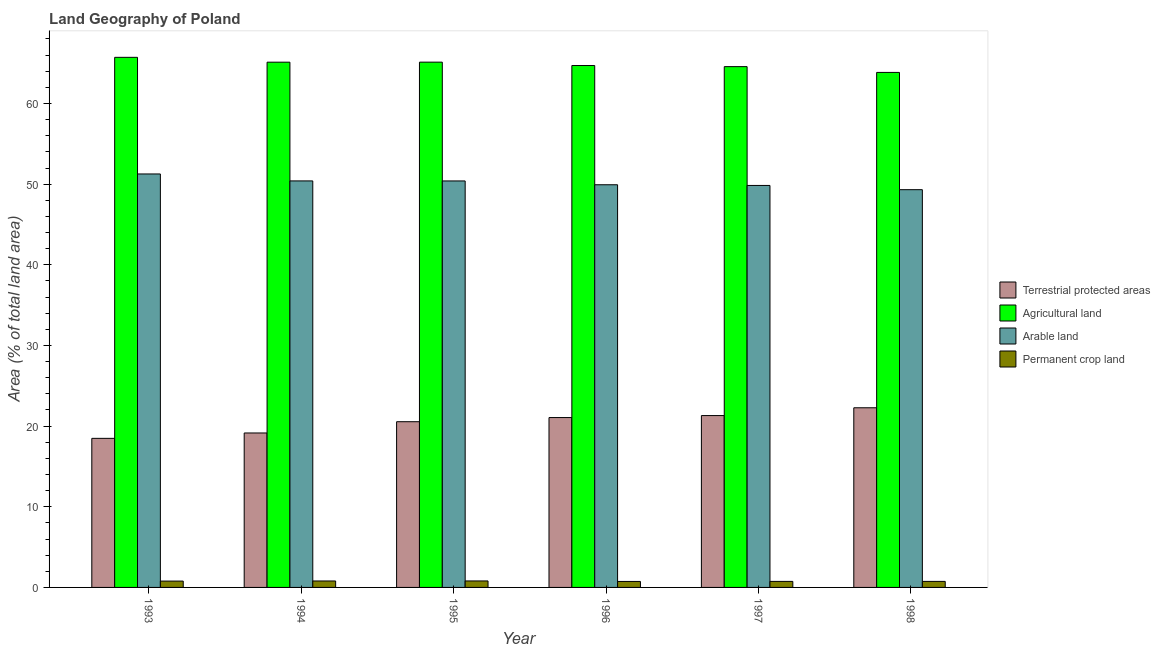Are the number of bars on each tick of the X-axis equal?
Your answer should be compact. Yes. What is the percentage of area under agricultural land in 1993?
Make the answer very short. 65.72. Across all years, what is the maximum percentage of land under terrestrial protection?
Your response must be concise. 22.27. Across all years, what is the minimum percentage of area under agricultural land?
Provide a succinct answer. 63.85. What is the total percentage of area under agricultural land in the graph?
Your response must be concise. 389.1. What is the difference between the percentage of area under permanent crop land in 1994 and that in 1998?
Keep it short and to the point. 0.05. What is the difference between the percentage of area under agricultural land in 1995 and the percentage of area under permanent crop land in 1994?
Your answer should be very brief. 0. What is the average percentage of area under agricultural land per year?
Keep it short and to the point. 64.85. In the year 1997, what is the difference between the percentage of area under permanent crop land and percentage of area under arable land?
Your answer should be compact. 0. What is the ratio of the percentage of area under permanent crop land in 1996 to that in 1997?
Your answer should be compact. 0.99. Is the percentage of area under permanent crop land in 1993 less than that in 1996?
Your response must be concise. No. What is the difference between the highest and the second highest percentage of area under agricultural land?
Give a very brief answer. 0.6. What is the difference between the highest and the lowest percentage of land under terrestrial protection?
Your answer should be compact. 3.79. In how many years, is the percentage of area under agricultural land greater than the average percentage of area under agricultural land taken over all years?
Offer a terse response. 3. Is the sum of the percentage of area under permanent crop land in 1993 and 1996 greater than the maximum percentage of area under arable land across all years?
Keep it short and to the point. Yes. What does the 4th bar from the left in 1995 represents?
Your response must be concise. Permanent crop land. What does the 4th bar from the right in 1995 represents?
Keep it short and to the point. Terrestrial protected areas. Where does the legend appear in the graph?
Offer a very short reply. Center right. How many legend labels are there?
Offer a terse response. 4. How are the legend labels stacked?
Your answer should be very brief. Vertical. What is the title of the graph?
Offer a very short reply. Land Geography of Poland. Does "Others" appear as one of the legend labels in the graph?
Offer a very short reply. No. What is the label or title of the Y-axis?
Offer a terse response. Area (% of total land area). What is the Area (% of total land area) in Terrestrial protected areas in 1993?
Offer a terse response. 18.48. What is the Area (% of total land area) of Agricultural land in 1993?
Provide a succinct answer. 65.72. What is the Area (% of total land area) of Arable land in 1993?
Make the answer very short. 51.26. What is the Area (% of total land area) of Permanent crop land in 1993?
Your answer should be very brief. 0.79. What is the Area (% of total land area) of Terrestrial protected areas in 1994?
Give a very brief answer. 19.15. What is the Area (% of total land area) of Agricultural land in 1994?
Provide a short and direct response. 65.12. What is the Area (% of total land area) of Arable land in 1994?
Give a very brief answer. 50.4. What is the Area (% of total land area) of Permanent crop land in 1994?
Ensure brevity in your answer.  0.8. What is the Area (% of total land area) in Terrestrial protected areas in 1995?
Offer a very short reply. 20.55. What is the Area (% of total land area) in Agricultural land in 1995?
Ensure brevity in your answer.  65.12. What is the Area (% of total land area) in Arable land in 1995?
Make the answer very short. 50.4. What is the Area (% of total land area) in Permanent crop land in 1995?
Ensure brevity in your answer.  0.8. What is the Area (% of total land area) in Terrestrial protected areas in 1996?
Offer a very short reply. 21.06. What is the Area (% of total land area) in Agricultural land in 1996?
Offer a very short reply. 64.71. What is the Area (% of total land area) of Arable land in 1996?
Provide a succinct answer. 49.92. What is the Area (% of total land area) of Permanent crop land in 1996?
Ensure brevity in your answer.  0.74. What is the Area (% of total land area) of Terrestrial protected areas in 1997?
Your response must be concise. 21.31. What is the Area (% of total land area) in Agricultural land in 1997?
Ensure brevity in your answer.  64.57. What is the Area (% of total land area) of Arable land in 1997?
Make the answer very short. 49.84. What is the Area (% of total land area) of Permanent crop land in 1997?
Make the answer very short. 0.75. What is the Area (% of total land area) of Terrestrial protected areas in 1998?
Keep it short and to the point. 22.27. What is the Area (% of total land area) of Agricultural land in 1998?
Ensure brevity in your answer.  63.85. What is the Area (% of total land area) of Arable land in 1998?
Make the answer very short. 49.31. What is the Area (% of total land area) in Permanent crop land in 1998?
Provide a succinct answer. 0.75. Across all years, what is the maximum Area (% of total land area) in Terrestrial protected areas?
Make the answer very short. 22.27. Across all years, what is the maximum Area (% of total land area) of Agricultural land?
Provide a short and direct response. 65.72. Across all years, what is the maximum Area (% of total land area) of Arable land?
Ensure brevity in your answer.  51.26. Across all years, what is the maximum Area (% of total land area) of Permanent crop land?
Give a very brief answer. 0.8. Across all years, what is the minimum Area (% of total land area) in Terrestrial protected areas?
Keep it short and to the point. 18.48. Across all years, what is the minimum Area (% of total land area) of Agricultural land?
Make the answer very short. 63.85. Across all years, what is the minimum Area (% of total land area) of Arable land?
Offer a very short reply. 49.31. Across all years, what is the minimum Area (% of total land area) in Permanent crop land?
Your answer should be compact. 0.74. What is the total Area (% of total land area) in Terrestrial protected areas in the graph?
Offer a very short reply. 122.82. What is the total Area (% of total land area) of Agricultural land in the graph?
Offer a very short reply. 389.1. What is the total Area (% of total land area) of Arable land in the graph?
Your answer should be very brief. 301.13. What is the total Area (% of total land area) of Permanent crop land in the graph?
Offer a terse response. 4.63. What is the difference between the Area (% of total land area) of Terrestrial protected areas in 1993 and that in 1994?
Your response must be concise. -0.67. What is the difference between the Area (% of total land area) in Agricultural land in 1993 and that in 1994?
Keep it short and to the point. 0.6. What is the difference between the Area (% of total land area) of Arable land in 1993 and that in 1994?
Your answer should be compact. 0.86. What is the difference between the Area (% of total land area) of Permanent crop land in 1993 and that in 1994?
Give a very brief answer. -0.01. What is the difference between the Area (% of total land area) of Terrestrial protected areas in 1993 and that in 1995?
Provide a short and direct response. -2.06. What is the difference between the Area (% of total land area) in Agricultural land in 1993 and that in 1995?
Provide a short and direct response. 0.6. What is the difference between the Area (% of total land area) of Arable land in 1993 and that in 1995?
Offer a terse response. 0.87. What is the difference between the Area (% of total land area) of Permanent crop land in 1993 and that in 1995?
Keep it short and to the point. -0.02. What is the difference between the Area (% of total land area) in Terrestrial protected areas in 1993 and that in 1996?
Give a very brief answer. -2.58. What is the difference between the Area (% of total land area) of Agricultural land in 1993 and that in 1996?
Your answer should be compact. 1.02. What is the difference between the Area (% of total land area) in Arable land in 1993 and that in 1996?
Offer a terse response. 1.34. What is the difference between the Area (% of total land area) in Permanent crop land in 1993 and that in 1996?
Make the answer very short. 0.05. What is the difference between the Area (% of total land area) in Terrestrial protected areas in 1993 and that in 1997?
Make the answer very short. -2.82. What is the difference between the Area (% of total land area) of Agricultural land in 1993 and that in 1997?
Give a very brief answer. 1.15. What is the difference between the Area (% of total land area) in Arable land in 1993 and that in 1997?
Your answer should be compact. 1.42. What is the difference between the Area (% of total land area) in Permanent crop land in 1993 and that in 1997?
Offer a very short reply. 0.04. What is the difference between the Area (% of total land area) of Terrestrial protected areas in 1993 and that in 1998?
Keep it short and to the point. -3.79. What is the difference between the Area (% of total land area) of Agricultural land in 1993 and that in 1998?
Ensure brevity in your answer.  1.87. What is the difference between the Area (% of total land area) of Arable land in 1993 and that in 1998?
Your answer should be very brief. 1.95. What is the difference between the Area (% of total land area) of Permanent crop land in 1993 and that in 1998?
Make the answer very short. 0.04. What is the difference between the Area (% of total land area) in Terrestrial protected areas in 1994 and that in 1995?
Provide a succinct answer. -1.4. What is the difference between the Area (% of total land area) of Agricultural land in 1994 and that in 1995?
Your answer should be compact. -0. What is the difference between the Area (% of total land area) in Arable land in 1994 and that in 1995?
Provide a short and direct response. 0. What is the difference between the Area (% of total land area) of Permanent crop land in 1994 and that in 1995?
Your response must be concise. -0. What is the difference between the Area (% of total land area) in Terrestrial protected areas in 1994 and that in 1996?
Give a very brief answer. -1.91. What is the difference between the Area (% of total land area) of Agricultural land in 1994 and that in 1996?
Offer a terse response. 0.41. What is the difference between the Area (% of total land area) in Arable land in 1994 and that in 1996?
Give a very brief answer. 0.48. What is the difference between the Area (% of total land area) of Permanent crop land in 1994 and that in 1996?
Provide a succinct answer. 0.06. What is the difference between the Area (% of total land area) in Terrestrial protected areas in 1994 and that in 1997?
Make the answer very short. -2.16. What is the difference between the Area (% of total land area) in Agricultural land in 1994 and that in 1997?
Offer a very short reply. 0.55. What is the difference between the Area (% of total land area) of Arable land in 1994 and that in 1997?
Give a very brief answer. 0.56. What is the difference between the Area (% of total land area) in Permanent crop land in 1994 and that in 1997?
Ensure brevity in your answer.  0.05. What is the difference between the Area (% of total land area) in Terrestrial protected areas in 1994 and that in 1998?
Keep it short and to the point. -3.12. What is the difference between the Area (% of total land area) in Agricultural land in 1994 and that in 1998?
Your response must be concise. 1.27. What is the difference between the Area (% of total land area) in Arable land in 1994 and that in 1998?
Give a very brief answer. 1.09. What is the difference between the Area (% of total land area) of Permanent crop land in 1994 and that in 1998?
Your answer should be very brief. 0.05. What is the difference between the Area (% of total land area) in Terrestrial protected areas in 1995 and that in 1996?
Give a very brief answer. -0.52. What is the difference between the Area (% of total land area) of Agricultural land in 1995 and that in 1996?
Give a very brief answer. 0.42. What is the difference between the Area (% of total land area) in Arable land in 1995 and that in 1996?
Keep it short and to the point. 0.47. What is the difference between the Area (% of total land area) of Permanent crop land in 1995 and that in 1996?
Your response must be concise. 0.06. What is the difference between the Area (% of total land area) in Terrestrial protected areas in 1995 and that in 1997?
Give a very brief answer. -0.76. What is the difference between the Area (% of total land area) in Agricultural land in 1995 and that in 1997?
Offer a very short reply. 0.56. What is the difference between the Area (% of total land area) of Arable land in 1995 and that in 1997?
Provide a succinct answer. 0.56. What is the difference between the Area (% of total land area) in Permanent crop land in 1995 and that in 1997?
Offer a very short reply. 0.06. What is the difference between the Area (% of total land area) of Terrestrial protected areas in 1995 and that in 1998?
Offer a very short reply. -1.73. What is the difference between the Area (% of total land area) in Agricultural land in 1995 and that in 1998?
Offer a terse response. 1.27. What is the difference between the Area (% of total land area) in Arable land in 1995 and that in 1998?
Ensure brevity in your answer.  1.08. What is the difference between the Area (% of total land area) of Permanent crop land in 1995 and that in 1998?
Make the answer very short. 0.06. What is the difference between the Area (% of total land area) of Terrestrial protected areas in 1996 and that in 1997?
Offer a very short reply. -0.25. What is the difference between the Area (% of total land area) of Agricultural land in 1996 and that in 1997?
Provide a short and direct response. 0.14. What is the difference between the Area (% of total land area) in Arable land in 1996 and that in 1997?
Ensure brevity in your answer.  0.08. What is the difference between the Area (% of total land area) of Permanent crop land in 1996 and that in 1997?
Provide a succinct answer. -0.01. What is the difference between the Area (% of total land area) of Terrestrial protected areas in 1996 and that in 1998?
Offer a terse response. -1.21. What is the difference between the Area (% of total land area) in Agricultural land in 1996 and that in 1998?
Ensure brevity in your answer.  0.86. What is the difference between the Area (% of total land area) of Arable land in 1996 and that in 1998?
Your answer should be compact. 0.61. What is the difference between the Area (% of total land area) of Permanent crop land in 1996 and that in 1998?
Make the answer very short. -0.01. What is the difference between the Area (% of total land area) of Terrestrial protected areas in 1997 and that in 1998?
Keep it short and to the point. -0.97. What is the difference between the Area (% of total land area) in Agricultural land in 1997 and that in 1998?
Make the answer very short. 0.72. What is the difference between the Area (% of total land area) of Arable land in 1997 and that in 1998?
Give a very brief answer. 0.53. What is the difference between the Area (% of total land area) in Terrestrial protected areas in 1993 and the Area (% of total land area) in Agricultural land in 1994?
Provide a short and direct response. -46.64. What is the difference between the Area (% of total land area) of Terrestrial protected areas in 1993 and the Area (% of total land area) of Arable land in 1994?
Your answer should be very brief. -31.92. What is the difference between the Area (% of total land area) of Terrestrial protected areas in 1993 and the Area (% of total land area) of Permanent crop land in 1994?
Keep it short and to the point. 17.68. What is the difference between the Area (% of total land area) in Agricultural land in 1993 and the Area (% of total land area) in Arable land in 1994?
Ensure brevity in your answer.  15.32. What is the difference between the Area (% of total land area) of Agricultural land in 1993 and the Area (% of total land area) of Permanent crop land in 1994?
Make the answer very short. 64.92. What is the difference between the Area (% of total land area) of Arable land in 1993 and the Area (% of total land area) of Permanent crop land in 1994?
Ensure brevity in your answer.  50.46. What is the difference between the Area (% of total land area) of Terrestrial protected areas in 1993 and the Area (% of total land area) of Agricultural land in 1995?
Your answer should be very brief. -46.64. What is the difference between the Area (% of total land area) of Terrestrial protected areas in 1993 and the Area (% of total land area) of Arable land in 1995?
Make the answer very short. -31.91. What is the difference between the Area (% of total land area) in Terrestrial protected areas in 1993 and the Area (% of total land area) in Permanent crop land in 1995?
Your answer should be very brief. 17.68. What is the difference between the Area (% of total land area) in Agricultural land in 1993 and the Area (% of total land area) in Arable land in 1995?
Offer a very short reply. 15.33. What is the difference between the Area (% of total land area) in Agricultural land in 1993 and the Area (% of total land area) in Permanent crop land in 1995?
Make the answer very short. 64.92. What is the difference between the Area (% of total land area) in Arable land in 1993 and the Area (% of total land area) in Permanent crop land in 1995?
Keep it short and to the point. 50.46. What is the difference between the Area (% of total land area) in Terrestrial protected areas in 1993 and the Area (% of total land area) in Agricultural land in 1996?
Your answer should be very brief. -46.22. What is the difference between the Area (% of total land area) of Terrestrial protected areas in 1993 and the Area (% of total land area) of Arable land in 1996?
Ensure brevity in your answer.  -31.44. What is the difference between the Area (% of total land area) in Terrestrial protected areas in 1993 and the Area (% of total land area) in Permanent crop land in 1996?
Your response must be concise. 17.74. What is the difference between the Area (% of total land area) in Agricultural land in 1993 and the Area (% of total land area) in Arable land in 1996?
Ensure brevity in your answer.  15.8. What is the difference between the Area (% of total land area) of Agricultural land in 1993 and the Area (% of total land area) of Permanent crop land in 1996?
Your answer should be compact. 64.98. What is the difference between the Area (% of total land area) in Arable land in 1993 and the Area (% of total land area) in Permanent crop land in 1996?
Make the answer very short. 50.52. What is the difference between the Area (% of total land area) of Terrestrial protected areas in 1993 and the Area (% of total land area) of Agricultural land in 1997?
Offer a very short reply. -46.09. What is the difference between the Area (% of total land area) in Terrestrial protected areas in 1993 and the Area (% of total land area) in Arable land in 1997?
Keep it short and to the point. -31.36. What is the difference between the Area (% of total land area) in Terrestrial protected areas in 1993 and the Area (% of total land area) in Permanent crop land in 1997?
Offer a terse response. 17.73. What is the difference between the Area (% of total land area) in Agricultural land in 1993 and the Area (% of total land area) in Arable land in 1997?
Your response must be concise. 15.88. What is the difference between the Area (% of total land area) of Agricultural land in 1993 and the Area (% of total land area) of Permanent crop land in 1997?
Give a very brief answer. 64.97. What is the difference between the Area (% of total land area) in Arable land in 1993 and the Area (% of total land area) in Permanent crop land in 1997?
Make the answer very short. 50.51. What is the difference between the Area (% of total land area) in Terrestrial protected areas in 1993 and the Area (% of total land area) in Agricultural land in 1998?
Offer a terse response. -45.37. What is the difference between the Area (% of total land area) of Terrestrial protected areas in 1993 and the Area (% of total land area) of Arable land in 1998?
Give a very brief answer. -30.83. What is the difference between the Area (% of total land area) of Terrestrial protected areas in 1993 and the Area (% of total land area) of Permanent crop land in 1998?
Offer a very short reply. 17.73. What is the difference between the Area (% of total land area) in Agricultural land in 1993 and the Area (% of total land area) in Arable land in 1998?
Offer a terse response. 16.41. What is the difference between the Area (% of total land area) in Agricultural land in 1993 and the Area (% of total land area) in Permanent crop land in 1998?
Your answer should be very brief. 64.97. What is the difference between the Area (% of total land area) in Arable land in 1993 and the Area (% of total land area) in Permanent crop land in 1998?
Your answer should be compact. 50.51. What is the difference between the Area (% of total land area) in Terrestrial protected areas in 1994 and the Area (% of total land area) in Agricultural land in 1995?
Make the answer very short. -45.97. What is the difference between the Area (% of total land area) in Terrestrial protected areas in 1994 and the Area (% of total land area) in Arable land in 1995?
Your response must be concise. -31.25. What is the difference between the Area (% of total land area) of Terrestrial protected areas in 1994 and the Area (% of total land area) of Permanent crop land in 1995?
Offer a very short reply. 18.35. What is the difference between the Area (% of total land area) in Agricultural land in 1994 and the Area (% of total land area) in Arable land in 1995?
Keep it short and to the point. 14.72. What is the difference between the Area (% of total land area) in Agricultural land in 1994 and the Area (% of total land area) in Permanent crop land in 1995?
Offer a very short reply. 64.32. What is the difference between the Area (% of total land area) in Arable land in 1994 and the Area (% of total land area) in Permanent crop land in 1995?
Your answer should be compact. 49.6. What is the difference between the Area (% of total land area) of Terrestrial protected areas in 1994 and the Area (% of total land area) of Agricultural land in 1996?
Offer a very short reply. -45.56. What is the difference between the Area (% of total land area) in Terrestrial protected areas in 1994 and the Area (% of total land area) in Arable land in 1996?
Provide a succinct answer. -30.77. What is the difference between the Area (% of total land area) in Terrestrial protected areas in 1994 and the Area (% of total land area) in Permanent crop land in 1996?
Offer a very short reply. 18.41. What is the difference between the Area (% of total land area) in Agricultural land in 1994 and the Area (% of total land area) in Arable land in 1996?
Provide a short and direct response. 15.2. What is the difference between the Area (% of total land area) of Agricultural land in 1994 and the Area (% of total land area) of Permanent crop land in 1996?
Offer a very short reply. 64.38. What is the difference between the Area (% of total land area) in Arable land in 1994 and the Area (% of total land area) in Permanent crop land in 1996?
Provide a succinct answer. 49.66. What is the difference between the Area (% of total land area) in Terrestrial protected areas in 1994 and the Area (% of total land area) in Agricultural land in 1997?
Offer a terse response. -45.42. What is the difference between the Area (% of total land area) in Terrestrial protected areas in 1994 and the Area (% of total land area) in Arable land in 1997?
Provide a succinct answer. -30.69. What is the difference between the Area (% of total land area) of Terrestrial protected areas in 1994 and the Area (% of total land area) of Permanent crop land in 1997?
Make the answer very short. 18.4. What is the difference between the Area (% of total land area) in Agricultural land in 1994 and the Area (% of total land area) in Arable land in 1997?
Keep it short and to the point. 15.28. What is the difference between the Area (% of total land area) of Agricultural land in 1994 and the Area (% of total land area) of Permanent crop land in 1997?
Offer a very short reply. 64.37. What is the difference between the Area (% of total land area) in Arable land in 1994 and the Area (% of total land area) in Permanent crop land in 1997?
Offer a terse response. 49.65. What is the difference between the Area (% of total land area) of Terrestrial protected areas in 1994 and the Area (% of total land area) of Agricultural land in 1998?
Offer a terse response. -44.7. What is the difference between the Area (% of total land area) in Terrestrial protected areas in 1994 and the Area (% of total land area) in Arable land in 1998?
Give a very brief answer. -30.16. What is the difference between the Area (% of total land area) in Terrestrial protected areas in 1994 and the Area (% of total land area) in Permanent crop land in 1998?
Provide a succinct answer. 18.4. What is the difference between the Area (% of total land area) in Agricultural land in 1994 and the Area (% of total land area) in Arable land in 1998?
Your answer should be compact. 15.81. What is the difference between the Area (% of total land area) in Agricultural land in 1994 and the Area (% of total land area) in Permanent crop land in 1998?
Provide a succinct answer. 64.37. What is the difference between the Area (% of total land area) of Arable land in 1994 and the Area (% of total land area) of Permanent crop land in 1998?
Provide a succinct answer. 49.65. What is the difference between the Area (% of total land area) of Terrestrial protected areas in 1995 and the Area (% of total land area) of Agricultural land in 1996?
Offer a terse response. -44.16. What is the difference between the Area (% of total land area) of Terrestrial protected areas in 1995 and the Area (% of total land area) of Arable land in 1996?
Offer a terse response. -29.38. What is the difference between the Area (% of total land area) in Terrestrial protected areas in 1995 and the Area (% of total land area) in Permanent crop land in 1996?
Your answer should be compact. 19.8. What is the difference between the Area (% of total land area) in Agricultural land in 1995 and the Area (% of total land area) in Arable land in 1996?
Provide a short and direct response. 15.2. What is the difference between the Area (% of total land area) in Agricultural land in 1995 and the Area (% of total land area) in Permanent crop land in 1996?
Offer a very short reply. 64.38. What is the difference between the Area (% of total land area) in Arable land in 1995 and the Area (% of total land area) in Permanent crop land in 1996?
Your answer should be compact. 49.66. What is the difference between the Area (% of total land area) of Terrestrial protected areas in 1995 and the Area (% of total land area) of Agricultural land in 1997?
Offer a terse response. -44.02. What is the difference between the Area (% of total land area) in Terrestrial protected areas in 1995 and the Area (% of total land area) in Arable land in 1997?
Your answer should be very brief. -29.29. What is the difference between the Area (% of total land area) of Terrestrial protected areas in 1995 and the Area (% of total land area) of Permanent crop land in 1997?
Provide a short and direct response. 19.8. What is the difference between the Area (% of total land area) in Agricultural land in 1995 and the Area (% of total land area) in Arable land in 1997?
Give a very brief answer. 15.29. What is the difference between the Area (% of total land area) of Agricultural land in 1995 and the Area (% of total land area) of Permanent crop land in 1997?
Provide a succinct answer. 64.38. What is the difference between the Area (% of total land area) of Arable land in 1995 and the Area (% of total land area) of Permanent crop land in 1997?
Ensure brevity in your answer.  49.65. What is the difference between the Area (% of total land area) in Terrestrial protected areas in 1995 and the Area (% of total land area) in Agricultural land in 1998?
Your answer should be compact. -43.31. What is the difference between the Area (% of total land area) in Terrestrial protected areas in 1995 and the Area (% of total land area) in Arable land in 1998?
Offer a very short reply. -28.77. What is the difference between the Area (% of total land area) of Terrestrial protected areas in 1995 and the Area (% of total land area) of Permanent crop land in 1998?
Your answer should be compact. 19.8. What is the difference between the Area (% of total land area) of Agricultural land in 1995 and the Area (% of total land area) of Arable land in 1998?
Your response must be concise. 15.81. What is the difference between the Area (% of total land area) of Agricultural land in 1995 and the Area (% of total land area) of Permanent crop land in 1998?
Your answer should be very brief. 64.38. What is the difference between the Area (% of total land area) of Arable land in 1995 and the Area (% of total land area) of Permanent crop land in 1998?
Your answer should be compact. 49.65. What is the difference between the Area (% of total land area) of Terrestrial protected areas in 1996 and the Area (% of total land area) of Agricultural land in 1997?
Provide a short and direct response. -43.51. What is the difference between the Area (% of total land area) in Terrestrial protected areas in 1996 and the Area (% of total land area) in Arable land in 1997?
Provide a succinct answer. -28.78. What is the difference between the Area (% of total land area) in Terrestrial protected areas in 1996 and the Area (% of total land area) in Permanent crop land in 1997?
Ensure brevity in your answer.  20.31. What is the difference between the Area (% of total land area) in Agricultural land in 1996 and the Area (% of total land area) in Arable land in 1997?
Give a very brief answer. 14.87. What is the difference between the Area (% of total land area) in Agricultural land in 1996 and the Area (% of total land area) in Permanent crop land in 1997?
Make the answer very short. 63.96. What is the difference between the Area (% of total land area) of Arable land in 1996 and the Area (% of total land area) of Permanent crop land in 1997?
Ensure brevity in your answer.  49.18. What is the difference between the Area (% of total land area) of Terrestrial protected areas in 1996 and the Area (% of total land area) of Agricultural land in 1998?
Offer a very short reply. -42.79. What is the difference between the Area (% of total land area) of Terrestrial protected areas in 1996 and the Area (% of total land area) of Arable land in 1998?
Your answer should be very brief. -28.25. What is the difference between the Area (% of total land area) in Terrestrial protected areas in 1996 and the Area (% of total land area) in Permanent crop land in 1998?
Provide a short and direct response. 20.31. What is the difference between the Area (% of total land area) in Agricultural land in 1996 and the Area (% of total land area) in Arable land in 1998?
Offer a terse response. 15.39. What is the difference between the Area (% of total land area) of Agricultural land in 1996 and the Area (% of total land area) of Permanent crop land in 1998?
Offer a very short reply. 63.96. What is the difference between the Area (% of total land area) in Arable land in 1996 and the Area (% of total land area) in Permanent crop land in 1998?
Your response must be concise. 49.18. What is the difference between the Area (% of total land area) of Terrestrial protected areas in 1997 and the Area (% of total land area) of Agricultural land in 1998?
Give a very brief answer. -42.55. What is the difference between the Area (% of total land area) of Terrestrial protected areas in 1997 and the Area (% of total land area) of Arable land in 1998?
Give a very brief answer. -28.01. What is the difference between the Area (% of total land area) of Terrestrial protected areas in 1997 and the Area (% of total land area) of Permanent crop land in 1998?
Your answer should be very brief. 20.56. What is the difference between the Area (% of total land area) of Agricultural land in 1997 and the Area (% of total land area) of Arable land in 1998?
Keep it short and to the point. 15.26. What is the difference between the Area (% of total land area) in Agricultural land in 1997 and the Area (% of total land area) in Permanent crop land in 1998?
Offer a very short reply. 63.82. What is the difference between the Area (% of total land area) in Arable land in 1997 and the Area (% of total land area) in Permanent crop land in 1998?
Give a very brief answer. 49.09. What is the average Area (% of total land area) of Terrestrial protected areas per year?
Offer a very short reply. 20.47. What is the average Area (% of total land area) in Agricultural land per year?
Your answer should be very brief. 64.85. What is the average Area (% of total land area) of Arable land per year?
Your answer should be very brief. 50.19. What is the average Area (% of total land area) in Permanent crop land per year?
Give a very brief answer. 0.77. In the year 1993, what is the difference between the Area (% of total land area) in Terrestrial protected areas and Area (% of total land area) in Agricultural land?
Give a very brief answer. -47.24. In the year 1993, what is the difference between the Area (% of total land area) of Terrestrial protected areas and Area (% of total land area) of Arable land?
Make the answer very short. -32.78. In the year 1993, what is the difference between the Area (% of total land area) of Terrestrial protected areas and Area (% of total land area) of Permanent crop land?
Your answer should be very brief. 17.7. In the year 1993, what is the difference between the Area (% of total land area) in Agricultural land and Area (% of total land area) in Arable land?
Ensure brevity in your answer.  14.46. In the year 1993, what is the difference between the Area (% of total land area) in Agricultural land and Area (% of total land area) in Permanent crop land?
Make the answer very short. 64.94. In the year 1993, what is the difference between the Area (% of total land area) of Arable land and Area (% of total land area) of Permanent crop land?
Offer a very short reply. 50.48. In the year 1994, what is the difference between the Area (% of total land area) of Terrestrial protected areas and Area (% of total land area) of Agricultural land?
Your answer should be compact. -45.97. In the year 1994, what is the difference between the Area (% of total land area) in Terrestrial protected areas and Area (% of total land area) in Arable land?
Offer a very short reply. -31.25. In the year 1994, what is the difference between the Area (% of total land area) of Terrestrial protected areas and Area (% of total land area) of Permanent crop land?
Your answer should be compact. 18.35. In the year 1994, what is the difference between the Area (% of total land area) of Agricultural land and Area (% of total land area) of Arable land?
Your answer should be compact. 14.72. In the year 1994, what is the difference between the Area (% of total land area) of Agricultural land and Area (% of total land area) of Permanent crop land?
Provide a succinct answer. 64.32. In the year 1994, what is the difference between the Area (% of total land area) in Arable land and Area (% of total land area) in Permanent crop land?
Provide a succinct answer. 49.6. In the year 1995, what is the difference between the Area (% of total land area) of Terrestrial protected areas and Area (% of total land area) of Agricultural land?
Your response must be concise. -44.58. In the year 1995, what is the difference between the Area (% of total land area) of Terrestrial protected areas and Area (% of total land area) of Arable land?
Ensure brevity in your answer.  -29.85. In the year 1995, what is the difference between the Area (% of total land area) in Terrestrial protected areas and Area (% of total land area) in Permanent crop land?
Offer a terse response. 19.74. In the year 1995, what is the difference between the Area (% of total land area) of Agricultural land and Area (% of total land area) of Arable land?
Make the answer very short. 14.73. In the year 1995, what is the difference between the Area (% of total land area) of Agricultural land and Area (% of total land area) of Permanent crop land?
Give a very brief answer. 64.32. In the year 1995, what is the difference between the Area (% of total land area) of Arable land and Area (% of total land area) of Permanent crop land?
Provide a succinct answer. 49.59. In the year 1996, what is the difference between the Area (% of total land area) in Terrestrial protected areas and Area (% of total land area) in Agricultural land?
Provide a succinct answer. -43.65. In the year 1996, what is the difference between the Area (% of total land area) in Terrestrial protected areas and Area (% of total land area) in Arable land?
Your answer should be compact. -28.86. In the year 1996, what is the difference between the Area (% of total land area) of Terrestrial protected areas and Area (% of total land area) of Permanent crop land?
Give a very brief answer. 20.32. In the year 1996, what is the difference between the Area (% of total land area) in Agricultural land and Area (% of total land area) in Arable land?
Your response must be concise. 14.78. In the year 1996, what is the difference between the Area (% of total land area) in Agricultural land and Area (% of total land area) in Permanent crop land?
Your answer should be very brief. 63.97. In the year 1996, what is the difference between the Area (% of total land area) in Arable land and Area (% of total land area) in Permanent crop land?
Your answer should be compact. 49.18. In the year 1997, what is the difference between the Area (% of total land area) of Terrestrial protected areas and Area (% of total land area) of Agricultural land?
Ensure brevity in your answer.  -43.26. In the year 1997, what is the difference between the Area (% of total land area) in Terrestrial protected areas and Area (% of total land area) in Arable land?
Provide a succinct answer. -28.53. In the year 1997, what is the difference between the Area (% of total land area) of Terrestrial protected areas and Area (% of total land area) of Permanent crop land?
Ensure brevity in your answer.  20.56. In the year 1997, what is the difference between the Area (% of total land area) of Agricultural land and Area (% of total land area) of Arable land?
Keep it short and to the point. 14.73. In the year 1997, what is the difference between the Area (% of total land area) in Agricultural land and Area (% of total land area) in Permanent crop land?
Your answer should be compact. 63.82. In the year 1997, what is the difference between the Area (% of total land area) in Arable land and Area (% of total land area) in Permanent crop land?
Offer a terse response. 49.09. In the year 1998, what is the difference between the Area (% of total land area) in Terrestrial protected areas and Area (% of total land area) in Agricultural land?
Offer a very short reply. -41.58. In the year 1998, what is the difference between the Area (% of total land area) of Terrestrial protected areas and Area (% of total land area) of Arable land?
Keep it short and to the point. -27.04. In the year 1998, what is the difference between the Area (% of total land area) of Terrestrial protected areas and Area (% of total land area) of Permanent crop land?
Ensure brevity in your answer.  21.53. In the year 1998, what is the difference between the Area (% of total land area) in Agricultural land and Area (% of total land area) in Arable land?
Your response must be concise. 14.54. In the year 1998, what is the difference between the Area (% of total land area) in Agricultural land and Area (% of total land area) in Permanent crop land?
Offer a very short reply. 63.1. In the year 1998, what is the difference between the Area (% of total land area) in Arable land and Area (% of total land area) in Permanent crop land?
Offer a very short reply. 48.57. What is the ratio of the Area (% of total land area) of Terrestrial protected areas in 1993 to that in 1994?
Offer a very short reply. 0.97. What is the ratio of the Area (% of total land area) in Agricultural land in 1993 to that in 1994?
Offer a very short reply. 1.01. What is the ratio of the Area (% of total land area) of Arable land in 1993 to that in 1994?
Your response must be concise. 1.02. What is the ratio of the Area (% of total land area) of Permanent crop land in 1993 to that in 1994?
Ensure brevity in your answer.  0.98. What is the ratio of the Area (% of total land area) of Terrestrial protected areas in 1993 to that in 1995?
Give a very brief answer. 0.9. What is the ratio of the Area (% of total land area) of Agricultural land in 1993 to that in 1995?
Provide a short and direct response. 1.01. What is the ratio of the Area (% of total land area) of Arable land in 1993 to that in 1995?
Your answer should be very brief. 1.02. What is the ratio of the Area (% of total land area) of Permanent crop land in 1993 to that in 1995?
Provide a short and direct response. 0.98. What is the ratio of the Area (% of total land area) in Terrestrial protected areas in 1993 to that in 1996?
Offer a very short reply. 0.88. What is the ratio of the Area (% of total land area) of Agricultural land in 1993 to that in 1996?
Your answer should be very brief. 1.02. What is the ratio of the Area (% of total land area) in Arable land in 1993 to that in 1996?
Give a very brief answer. 1.03. What is the ratio of the Area (% of total land area) of Permanent crop land in 1993 to that in 1996?
Offer a very short reply. 1.06. What is the ratio of the Area (% of total land area) of Terrestrial protected areas in 1993 to that in 1997?
Your answer should be very brief. 0.87. What is the ratio of the Area (% of total land area) of Agricultural land in 1993 to that in 1997?
Make the answer very short. 1.02. What is the ratio of the Area (% of total land area) in Arable land in 1993 to that in 1997?
Give a very brief answer. 1.03. What is the ratio of the Area (% of total land area) in Permanent crop land in 1993 to that in 1997?
Offer a terse response. 1.05. What is the ratio of the Area (% of total land area) in Terrestrial protected areas in 1993 to that in 1998?
Offer a very short reply. 0.83. What is the ratio of the Area (% of total land area) of Agricultural land in 1993 to that in 1998?
Give a very brief answer. 1.03. What is the ratio of the Area (% of total land area) of Arable land in 1993 to that in 1998?
Offer a very short reply. 1.04. What is the ratio of the Area (% of total land area) in Permanent crop land in 1993 to that in 1998?
Ensure brevity in your answer.  1.05. What is the ratio of the Area (% of total land area) in Terrestrial protected areas in 1994 to that in 1995?
Keep it short and to the point. 0.93. What is the ratio of the Area (% of total land area) in Terrestrial protected areas in 1994 to that in 1996?
Offer a terse response. 0.91. What is the ratio of the Area (% of total land area) of Agricultural land in 1994 to that in 1996?
Provide a succinct answer. 1.01. What is the ratio of the Area (% of total land area) of Arable land in 1994 to that in 1996?
Provide a short and direct response. 1.01. What is the ratio of the Area (% of total land area) of Permanent crop land in 1994 to that in 1996?
Offer a very short reply. 1.08. What is the ratio of the Area (% of total land area) in Terrestrial protected areas in 1994 to that in 1997?
Offer a very short reply. 0.9. What is the ratio of the Area (% of total land area) in Agricultural land in 1994 to that in 1997?
Ensure brevity in your answer.  1.01. What is the ratio of the Area (% of total land area) in Arable land in 1994 to that in 1997?
Offer a terse response. 1.01. What is the ratio of the Area (% of total land area) of Permanent crop land in 1994 to that in 1997?
Your answer should be compact. 1.07. What is the ratio of the Area (% of total land area) in Terrestrial protected areas in 1994 to that in 1998?
Your answer should be very brief. 0.86. What is the ratio of the Area (% of total land area) of Agricultural land in 1994 to that in 1998?
Offer a terse response. 1.02. What is the ratio of the Area (% of total land area) in Arable land in 1994 to that in 1998?
Your answer should be very brief. 1.02. What is the ratio of the Area (% of total land area) in Permanent crop land in 1994 to that in 1998?
Ensure brevity in your answer.  1.07. What is the ratio of the Area (% of total land area) of Terrestrial protected areas in 1995 to that in 1996?
Your answer should be very brief. 0.98. What is the ratio of the Area (% of total land area) of Agricultural land in 1995 to that in 1996?
Ensure brevity in your answer.  1.01. What is the ratio of the Area (% of total land area) of Arable land in 1995 to that in 1996?
Provide a short and direct response. 1.01. What is the ratio of the Area (% of total land area) in Permanent crop land in 1995 to that in 1996?
Your answer should be compact. 1.08. What is the ratio of the Area (% of total land area) in Terrestrial protected areas in 1995 to that in 1997?
Make the answer very short. 0.96. What is the ratio of the Area (% of total land area) in Agricultural land in 1995 to that in 1997?
Keep it short and to the point. 1.01. What is the ratio of the Area (% of total land area) in Arable land in 1995 to that in 1997?
Ensure brevity in your answer.  1.01. What is the ratio of the Area (% of total land area) in Permanent crop land in 1995 to that in 1997?
Ensure brevity in your answer.  1.07. What is the ratio of the Area (% of total land area) in Terrestrial protected areas in 1995 to that in 1998?
Keep it short and to the point. 0.92. What is the ratio of the Area (% of total land area) of Agricultural land in 1995 to that in 1998?
Your response must be concise. 1.02. What is the ratio of the Area (% of total land area) of Permanent crop land in 1995 to that in 1998?
Ensure brevity in your answer.  1.07. What is the ratio of the Area (% of total land area) in Permanent crop land in 1996 to that in 1997?
Provide a succinct answer. 0.99. What is the ratio of the Area (% of total land area) of Terrestrial protected areas in 1996 to that in 1998?
Provide a short and direct response. 0.95. What is the ratio of the Area (% of total land area) of Agricultural land in 1996 to that in 1998?
Give a very brief answer. 1.01. What is the ratio of the Area (% of total land area) in Arable land in 1996 to that in 1998?
Provide a succinct answer. 1.01. What is the ratio of the Area (% of total land area) of Permanent crop land in 1996 to that in 1998?
Your response must be concise. 0.99. What is the ratio of the Area (% of total land area) in Terrestrial protected areas in 1997 to that in 1998?
Keep it short and to the point. 0.96. What is the ratio of the Area (% of total land area) in Agricultural land in 1997 to that in 1998?
Give a very brief answer. 1.01. What is the ratio of the Area (% of total land area) in Arable land in 1997 to that in 1998?
Provide a succinct answer. 1.01. What is the ratio of the Area (% of total land area) of Permanent crop land in 1997 to that in 1998?
Your response must be concise. 1. What is the difference between the highest and the second highest Area (% of total land area) in Terrestrial protected areas?
Your answer should be very brief. 0.97. What is the difference between the highest and the second highest Area (% of total land area) in Agricultural land?
Give a very brief answer. 0.6. What is the difference between the highest and the second highest Area (% of total land area) of Arable land?
Offer a very short reply. 0.86. What is the difference between the highest and the second highest Area (% of total land area) in Permanent crop land?
Keep it short and to the point. 0. What is the difference between the highest and the lowest Area (% of total land area) in Terrestrial protected areas?
Provide a succinct answer. 3.79. What is the difference between the highest and the lowest Area (% of total land area) of Agricultural land?
Offer a very short reply. 1.87. What is the difference between the highest and the lowest Area (% of total land area) in Arable land?
Offer a terse response. 1.95. What is the difference between the highest and the lowest Area (% of total land area) in Permanent crop land?
Your response must be concise. 0.06. 